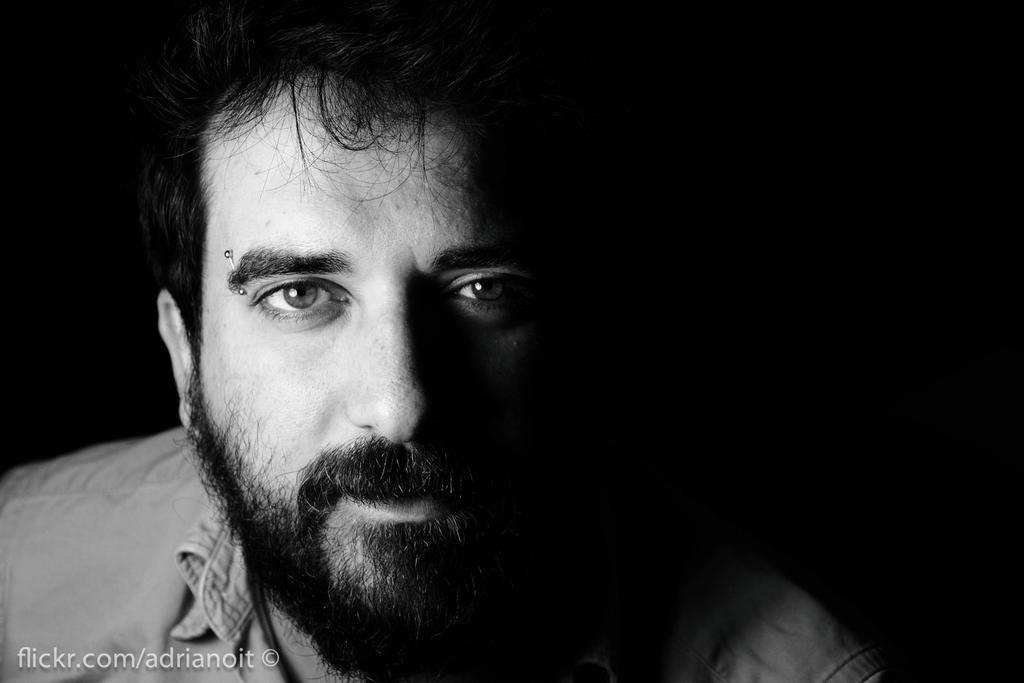What type of picture is in the image? The image contains a black and white picture of a person. What else can be seen in the image besides the picture? There is some text at the bottom of the image. How many legs are visible in the image? There are no legs visible in the image; it contains a picture of a person and text, but no legs. Is there a throne present in the image? There is no throne present in the image. 